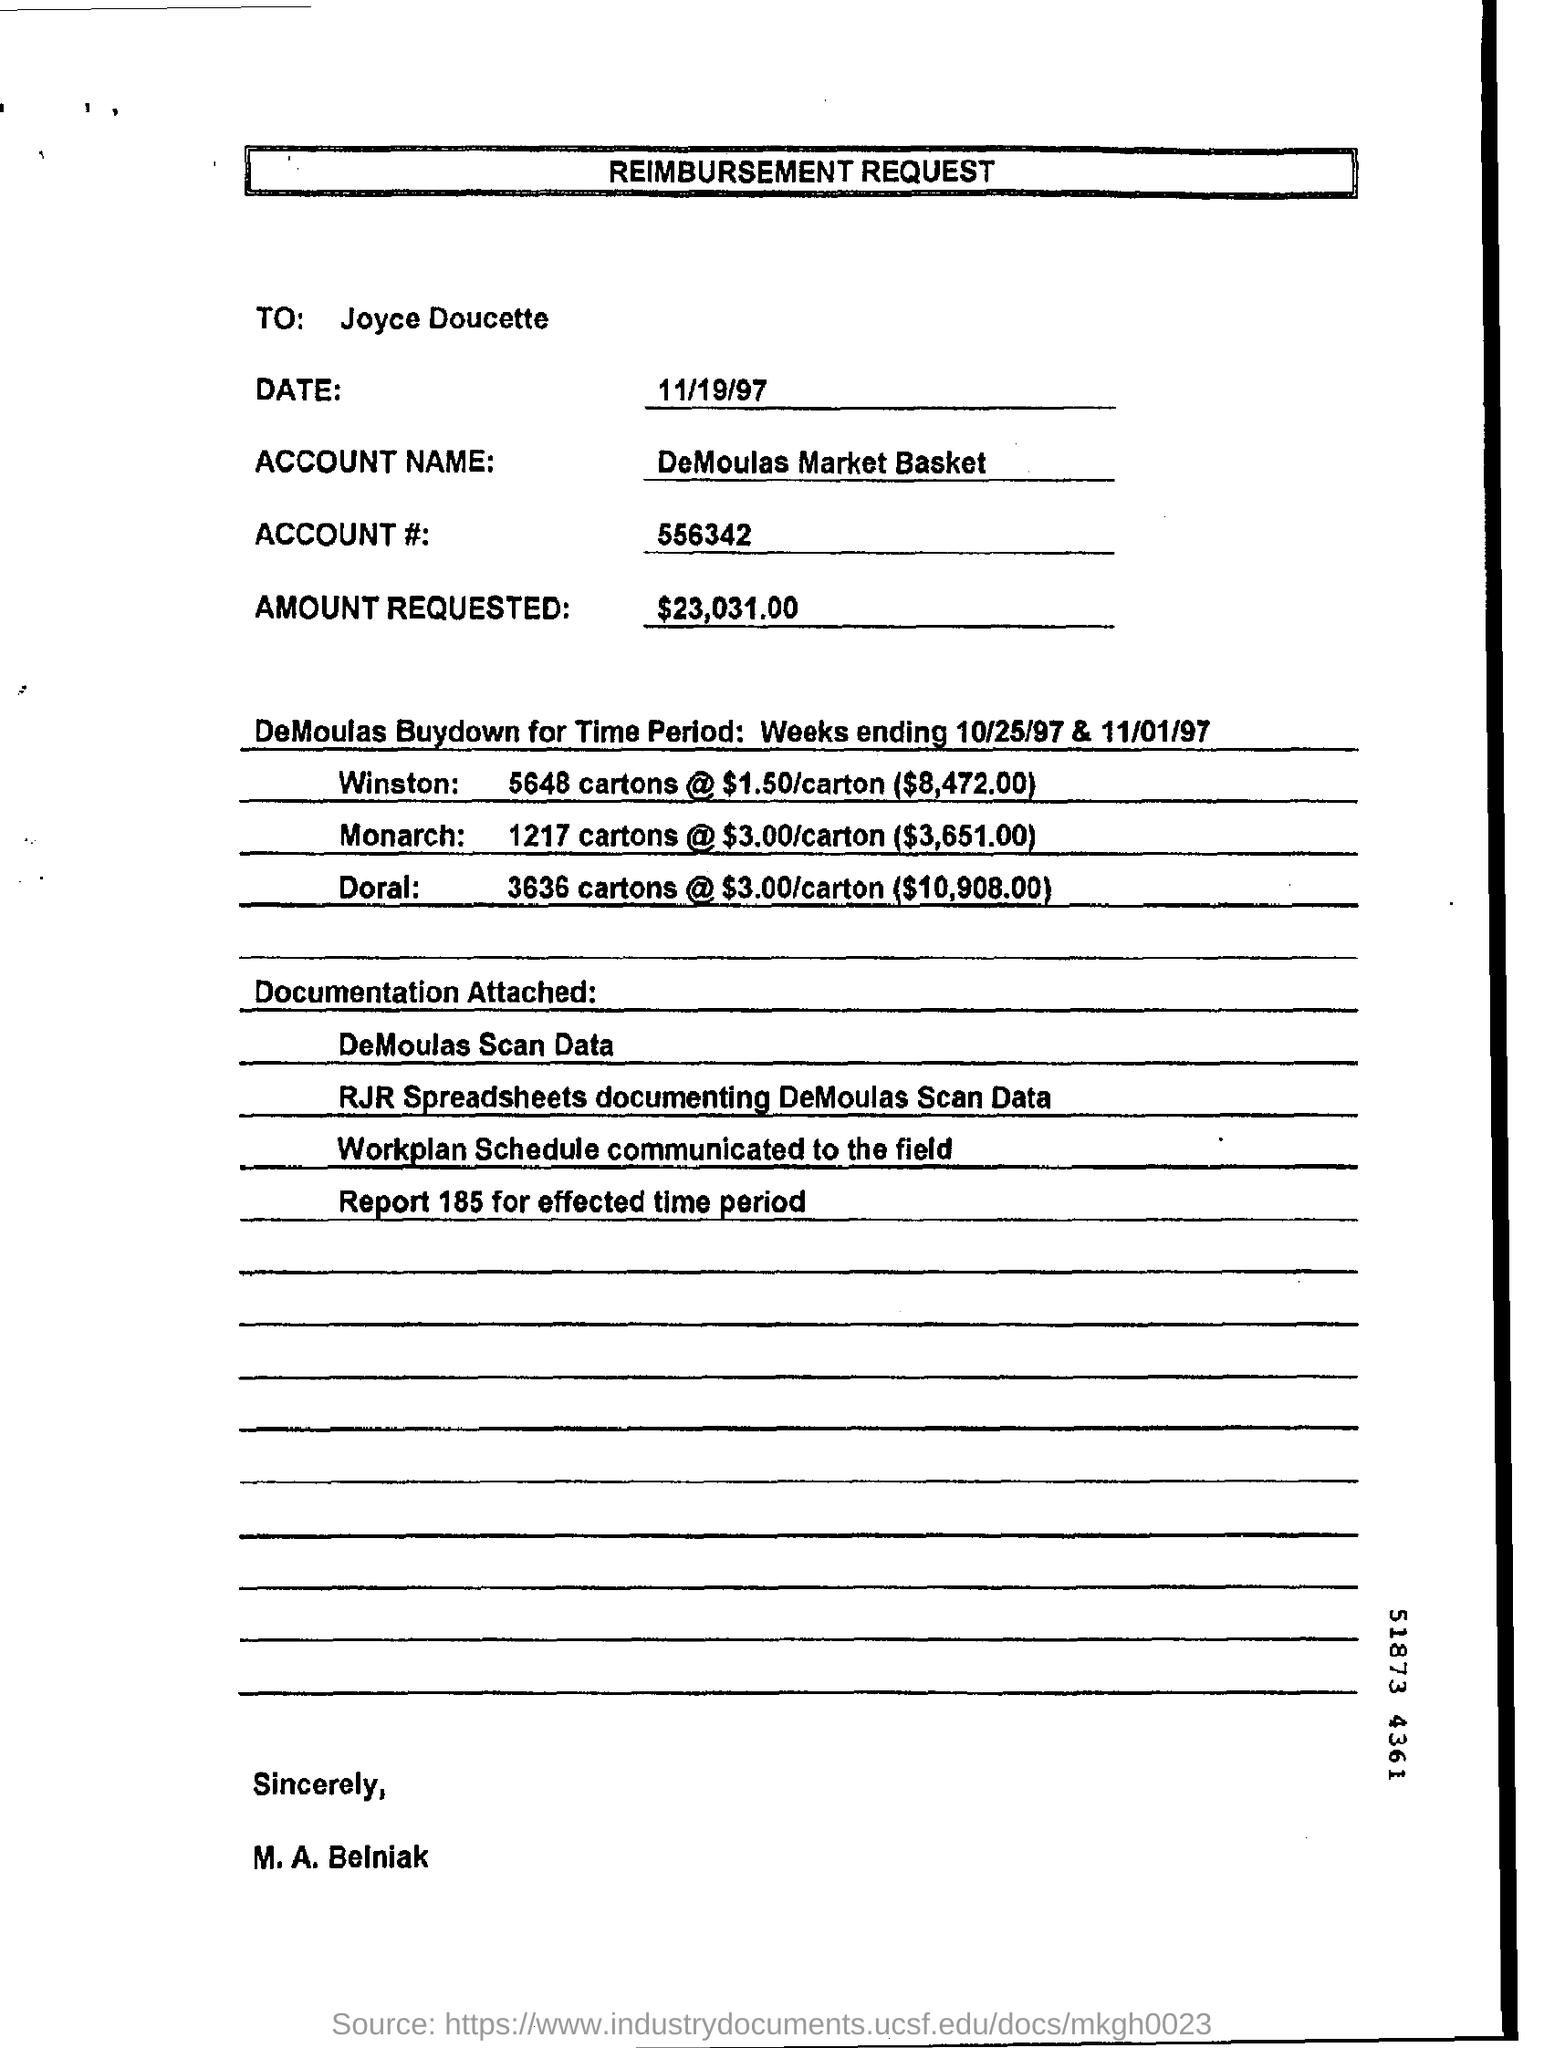Specify some key components in this picture. The heading of the document is 'Reimbursement Request.' This document is addressed to Joyce Doucette. The account name is DeMoulas Market Basket. The date mentioned is 11/19/97. 